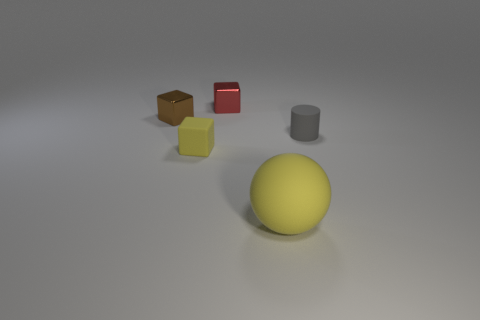There is a yellow ball; how many brown shiny objects are on the right side of it?
Your response must be concise. 0. Are there more gray things than large red metal cylinders?
Provide a short and direct response. Yes. There is a rubber thing that is on the right side of the tiny yellow object and behind the big yellow rubber thing; what shape is it?
Offer a terse response. Cylinder. Are any matte blocks visible?
Provide a succinct answer. Yes. There is a small brown object that is the same shape as the red metal object; what is its material?
Your answer should be compact. Metal. What shape is the thing that is behind the small metallic object that is on the left side of the yellow object that is behind the yellow sphere?
Offer a terse response. Cube. What is the material of the thing that is the same color as the big ball?
Ensure brevity in your answer.  Rubber. How many other small metallic things are the same shape as the tiny red metallic object?
Your answer should be compact. 1. Does the tiny cube in front of the small gray cylinder have the same color as the sphere that is to the right of the small brown cube?
Offer a terse response. Yes. What is the material of the red block that is the same size as the brown thing?
Keep it short and to the point. Metal. 